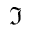<formula> <loc_0><loc_0><loc_500><loc_500>\Im</formula> 